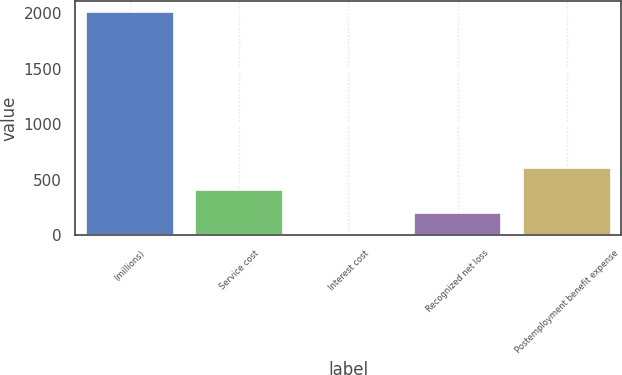<chart> <loc_0><loc_0><loc_500><loc_500><bar_chart><fcel>(millions)<fcel>Service cost<fcel>Interest cost<fcel>Recognized net loss<fcel>Postemployment benefit expense<nl><fcel>2012<fcel>405.6<fcel>4<fcel>204.8<fcel>606.4<nl></chart> 